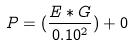<formula> <loc_0><loc_0><loc_500><loc_500>P = ( \frac { E * G } { 0 . 1 0 ^ { 2 } } ) + 0</formula> 